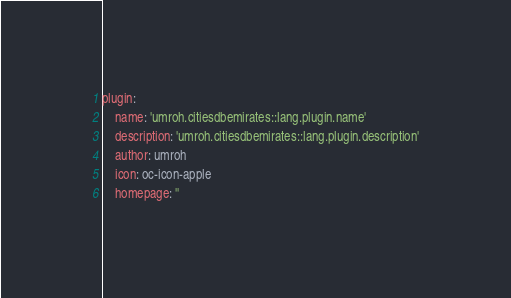Convert code to text. <code><loc_0><loc_0><loc_500><loc_500><_YAML_>plugin:
    name: 'umroh.citiesdbemirates::lang.plugin.name'
    description: 'umroh.citiesdbemirates::lang.plugin.description'
    author: umroh
    icon: oc-icon-apple
    homepage: ''
</code> 